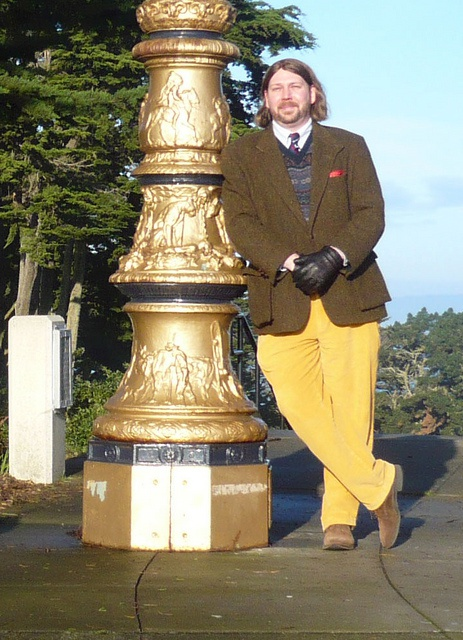Describe the objects in this image and their specific colors. I can see people in black, maroon, gold, and gray tones and tie in black, purple, darkgray, and gray tones in this image. 